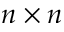<formula> <loc_0><loc_0><loc_500><loc_500>n \times n</formula> 